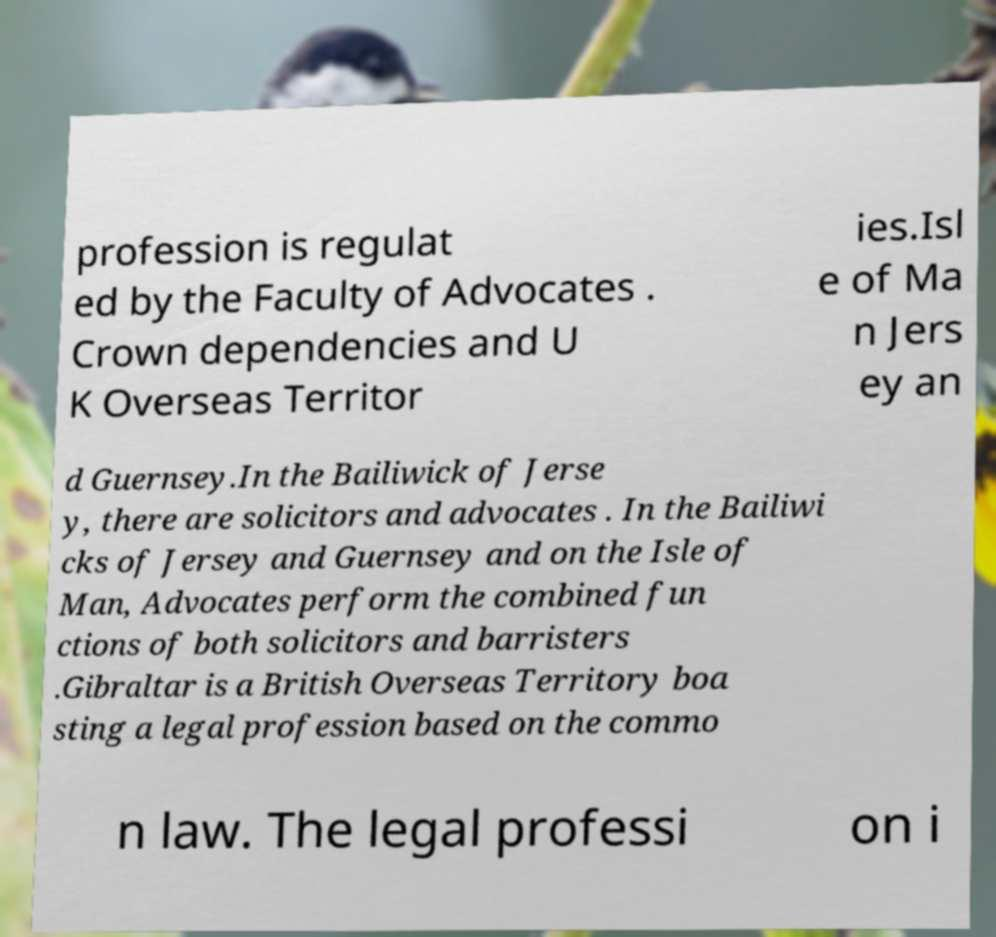Could you assist in decoding the text presented in this image and type it out clearly? profession is regulat ed by the Faculty of Advocates . Crown dependencies and U K Overseas Territor ies.Isl e of Ma n Jers ey an d Guernsey.In the Bailiwick of Jerse y, there are solicitors and advocates . In the Bailiwi cks of Jersey and Guernsey and on the Isle of Man, Advocates perform the combined fun ctions of both solicitors and barristers .Gibraltar is a British Overseas Territory boa sting a legal profession based on the commo n law. The legal professi on i 